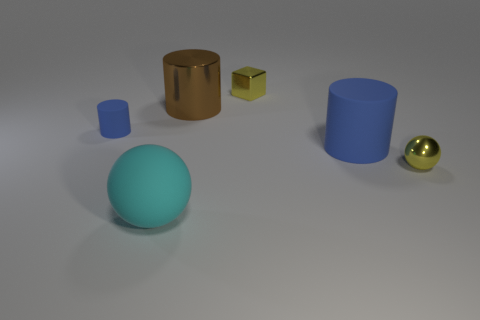Subtract all rubber cylinders. How many cylinders are left? 1 Add 1 small brown shiny things. How many objects exist? 7 Subtract all cyan balls. How many balls are left? 1 Subtract all blocks. How many objects are left? 5 Subtract 0 red balls. How many objects are left? 6 Subtract 1 balls. How many balls are left? 1 Subtract all green cubes. Subtract all blue balls. How many cubes are left? 1 Subtract all cyan blocks. How many yellow balls are left? 1 Subtract all brown blocks. Subtract all metallic cylinders. How many objects are left? 5 Add 5 blue rubber objects. How many blue rubber objects are left? 7 